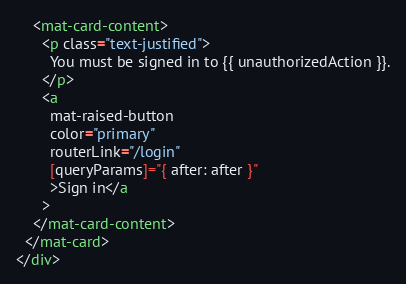Convert code to text. <code><loc_0><loc_0><loc_500><loc_500><_HTML_>    <mat-card-content>
      <p class="text-justified">
        You must be signed in to {{ unauthorizedAction }}.
      </p>
      <a
        mat-raised-button
        color="primary"
        routerLink="/login"
        [queryParams]="{ after: after }"
        >Sign in</a
      >
    </mat-card-content>
  </mat-card>
</div>
</code> 